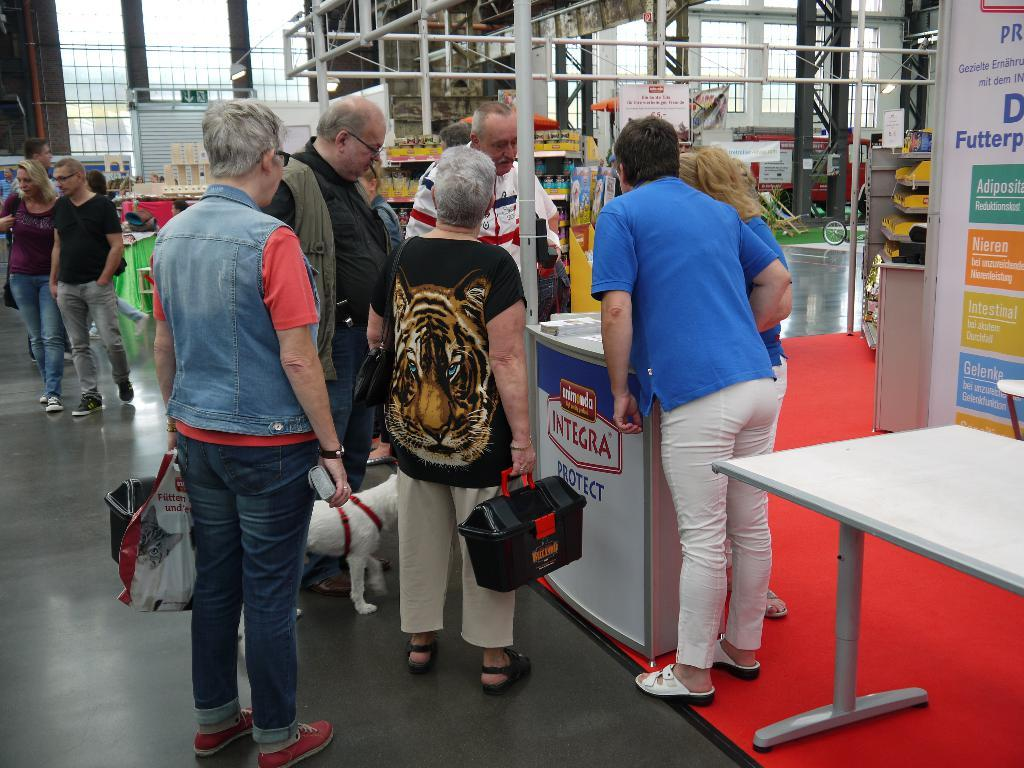Who or what can be seen in the image? There are people and a dog in the image. What is the dog doing in the image? The provided facts do not specify the dog's actions or position. What can be seen at the top of the image? There are rods visible at the top of the image. What color is the leather material in the image? There is no leather material present in the image. How does the sun affect the people and the dog in the image? The provided facts do not mention the presence of the sun in the image. 